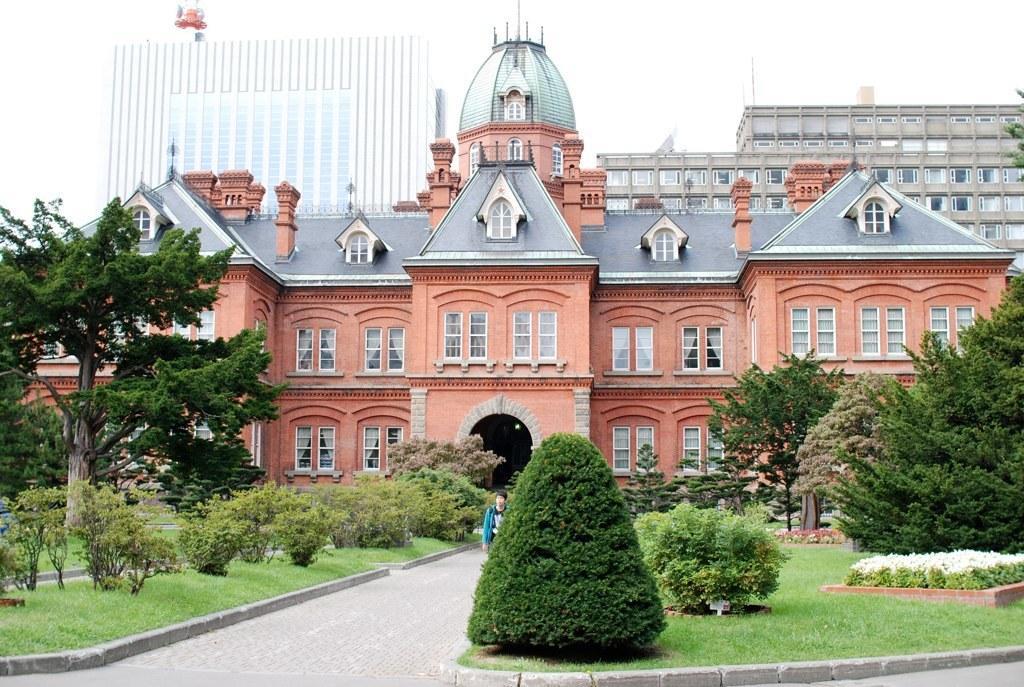In one or two sentences, can you explain what this image depicts? In the center of the image, we can see a man on the road and in the background, there are buildings, trees and plants. 